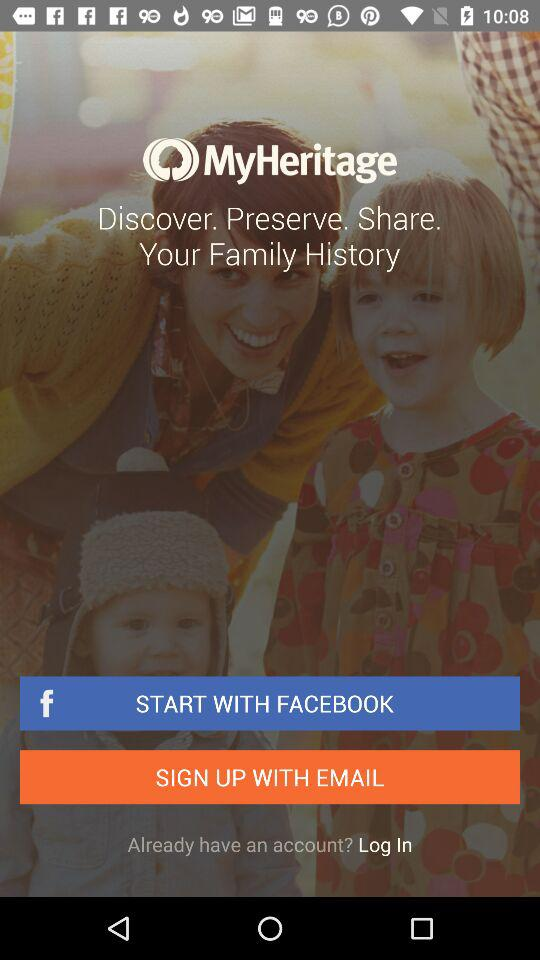What are the different options available for signing up? The different options available for signing up are "FACEBOOK" and "EMAIL". 